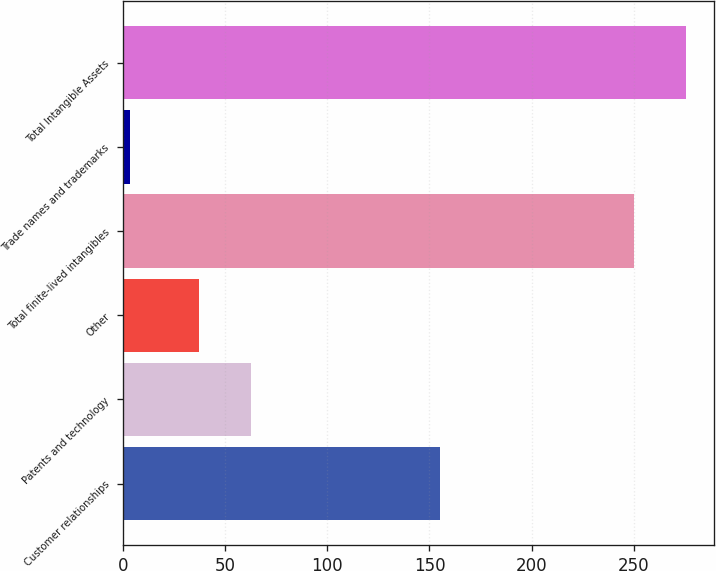Convert chart to OTSL. <chart><loc_0><loc_0><loc_500><loc_500><bar_chart><fcel>Customer relationships<fcel>Patents and technology<fcel>Other<fcel>Total finite-lived intangibles<fcel>Trade names and trademarks<fcel>Total Intangible Assets<nl><fcel>155.2<fcel>62.34<fcel>37.3<fcel>250.4<fcel>3.5<fcel>275.44<nl></chart> 